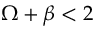<formula> <loc_0><loc_0><loc_500><loc_500>\Omega + \beta < 2</formula> 